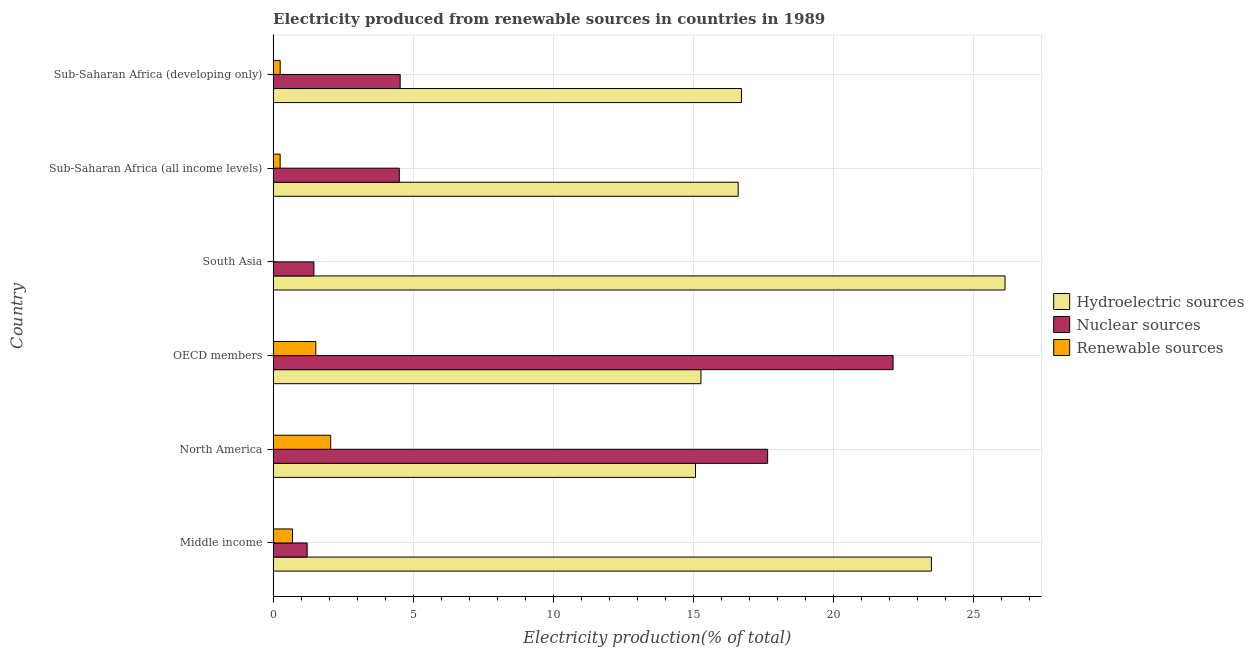How many different coloured bars are there?
Provide a short and direct response. 3. Are the number of bars per tick equal to the number of legend labels?
Give a very brief answer. Yes. How many bars are there on the 4th tick from the top?
Your response must be concise. 3. How many bars are there on the 3rd tick from the bottom?
Your answer should be compact. 3. What is the label of the 5th group of bars from the top?
Ensure brevity in your answer.  North America. What is the percentage of electricity produced by hydroelectric sources in Sub-Saharan Africa (all income levels)?
Your response must be concise. 16.61. Across all countries, what is the maximum percentage of electricity produced by hydroelectric sources?
Offer a terse response. 26.14. Across all countries, what is the minimum percentage of electricity produced by hydroelectric sources?
Your answer should be very brief. 15.09. In which country was the percentage of electricity produced by renewable sources minimum?
Your response must be concise. South Asia. What is the total percentage of electricity produced by renewable sources in the graph?
Provide a succinct answer. 4.78. What is the difference between the percentage of electricity produced by nuclear sources in North America and that in Sub-Saharan Africa (all income levels)?
Your answer should be compact. 13.16. What is the difference between the percentage of electricity produced by nuclear sources in South Asia and the percentage of electricity produced by renewable sources in Sub-Saharan Africa (developing only)?
Your response must be concise. 1.2. What is the average percentage of electricity produced by renewable sources per country?
Provide a succinct answer. 0.8. What is the difference between the percentage of electricity produced by renewable sources and percentage of electricity produced by hydroelectric sources in Middle income?
Give a very brief answer. -22.82. In how many countries, is the percentage of electricity produced by hydroelectric sources greater than 5 %?
Offer a very short reply. 6. What is the ratio of the percentage of electricity produced by nuclear sources in Middle income to that in North America?
Your response must be concise. 0.07. Is the percentage of electricity produced by nuclear sources in North America less than that in OECD members?
Keep it short and to the point. Yes. What is the difference between the highest and the second highest percentage of electricity produced by nuclear sources?
Ensure brevity in your answer.  4.48. What is the difference between the highest and the lowest percentage of electricity produced by renewable sources?
Provide a succinct answer. 2.05. In how many countries, is the percentage of electricity produced by renewable sources greater than the average percentage of electricity produced by renewable sources taken over all countries?
Your answer should be compact. 2. What does the 3rd bar from the top in Sub-Saharan Africa (all income levels) represents?
Offer a very short reply. Hydroelectric sources. What does the 3rd bar from the bottom in South Asia represents?
Provide a short and direct response. Renewable sources. Is it the case that in every country, the sum of the percentage of electricity produced by hydroelectric sources and percentage of electricity produced by nuclear sources is greater than the percentage of electricity produced by renewable sources?
Give a very brief answer. Yes. Are the values on the major ticks of X-axis written in scientific E-notation?
Your response must be concise. No. Does the graph contain any zero values?
Your response must be concise. No. What is the title of the graph?
Keep it short and to the point. Electricity produced from renewable sources in countries in 1989. Does "Other sectors" appear as one of the legend labels in the graph?
Your answer should be very brief. No. What is the label or title of the X-axis?
Provide a succinct answer. Electricity production(% of total). What is the Electricity production(% of total) of Hydroelectric sources in Middle income?
Your answer should be very brief. 23.51. What is the Electricity production(% of total) of Nuclear sources in Middle income?
Provide a short and direct response. 1.22. What is the Electricity production(% of total) of Renewable sources in Middle income?
Provide a short and direct response. 0.69. What is the Electricity production(% of total) of Hydroelectric sources in North America?
Your answer should be compact. 15.09. What is the Electricity production(% of total) of Nuclear sources in North America?
Offer a terse response. 17.66. What is the Electricity production(% of total) of Renewable sources in North America?
Make the answer very short. 2.06. What is the Electricity production(% of total) of Hydroelectric sources in OECD members?
Keep it short and to the point. 15.28. What is the Electricity production(% of total) in Nuclear sources in OECD members?
Make the answer very short. 22.15. What is the Electricity production(% of total) in Renewable sources in OECD members?
Give a very brief answer. 1.53. What is the Electricity production(% of total) in Hydroelectric sources in South Asia?
Make the answer very short. 26.14. What is the Electricity production(% of total) in Nuclear sources in South Asia?
Keep it short and to the point. 1.46. What is the Electricity production(% of total) of Renewable sources in South Asia?
Offer a very short reply. 0. What is the Electricity production(% of total) in Hydroelectric sources in Sub-Saharan Africa (all income levels)?
Offer a very short reply. 16.61. What is the Electricity production(% of total) in Nuclear sources in Sub-Saharan Africa (all income levels)?
Your answer should be very brief. 4.51. What is the Electricity production(% of total) in Renewable sources in Sub-Saharan Africa (all income levels)?
Offer a very short reply. 0.25. What is the Electricity production(% of total) in Hydroelectric sources in Sub-Saharan Africa (developing only)?
Your answer should be compact. 16.73. What is the Electricity production(% of total) of Nuclear sources in Sub-Saharan Africa (developing only)?
Give a very brief answer. 4.54. What is the Electricity production(% of total) of Renewable sources in Sub-Saharan Africa (developing only)?
Make the answer very short. 0.25. Across all countries, what is the maximum Electricity production(% of total) of Hydroelectric sources?
Offer a terse response. 26.14. Across all countries, what is the maximum Electricity production(% of total) of Nuclear sources?
Your answer should be compact. 22.15. Across all countries, what is the maximum Electricity production(% of total) in Renewable sources?
Offer a very short reply. 2.06. Across all countries, what is the minimum Electricity production(% of total) in Hydroelectric sources?
Your response must be concise. 15.09. Across all countries, what is the minimum Electricity production(% of total) in Nuclear sources?
Your answer should be compact. 1.22. Across all countries, what is the minimum Electricity production(% of total) in Renewable sources?
Provide a short and direct response. 0. What is the total Electricity production(% of total) of Hydroelectric sources in the graph?
Make the answer very short. 113.37. What is the total Electricity production(% of total) of Nuclear sources in the graph?
Keep it short and to the point. 51.53. What is the total Electricity production(% of total) in Renewable sources in the graph?
Your answer should be compact. 4.78. What is the difference between the Electricity production(% of total) in Hydroelectric sources in Middle income and that in North America?
Your response must be concise. 8.43. What is the difference between the Electricity production(% of total) of Nuclear sources in Middle income and that in North America?
Your response must be concise. -16.45. What is the difference between the Electricity production(% of total) in Renewable sources in Middle income and that in North America?
Your answer should be compact. -1.36. What is the difference between the Electricity production(% of total) of Hydroelectric sources in Middle income and that in OECD members?
Your response must be concise. 8.23. What is the difference between the Electricity production(% of total) in Nuclear sources in Middle income and that in OECD members?
Offer a very short reply. -20.93. What is the difference between the Electricity production(% of total) in Renewable sources in Middle income and that in OECD members?
Keep it short and to the point. -0.83. What is the difference between the Electricity production(% of total) of Hydroelectric sources in Middle income and that in South Asia?
Keep it short and to the point. -2.63. What is the difference between the Electricity production(% of total) in Nuclear sources in Middle income and that in South Asia?
Offer a very short reply. -0.24. What is the difference between the Electricity production(% of total) of Renewable sources in Middle income and that in South Asia?
Your response must be concise. 0.69. What is the difference between the Electricity production(% of total) in Hydroelectric sources in Middle income and that in Sub-Saharan Africa (all income levels)?
Your response must be concise. 6.9. What is the difference between the Electricity production(% of total) in Nuclear sources in Middle income and that in Sub-Saharan Africa (all income levels)?
Provide a short and direct response. -3.29. What is the difference between the Electricity production(% of total) in Renewable sources in Middle income and that in Sub-Saharan Africa (all income levels)?
Keep it short and to the point. 0.44. What is the difference between the Electricity production(% of total) in Hydroelectric sources in Middle income and that in Sub-Saharan Africa (developing only)?
Make the answer very short. 6.79. What is the difference between the Electricity production(% of total) in Nuclear sources in Middle income and that in Sub-Saharan Africa (developing only)?
Your answer should be very brief. -3.32. What is the difference between the Electricity production(% of total) of Renewable sources in Middle income and that in Sub-Saharan Africa (developing only)?
Your response must be concise. 0.44. What is the difference between the Electricity production(% of total) of Hydroelectric sources in North America and that in OECD members?
Your answer should be compact. -0.19. What is the difference between the Electricity production(% of total) in Nuclear sources in North America and that in OECD members?
Provide a succinct answer. -4.48. What is the difference between the Electricity production(% of total) of Renewable sources in North America and that in OECD members?
Your answer should be compact. 0.53. What is the difference between the Electricity production(% of total) of Hydroelectric sources in North America and that in South Asia?
Offer a terse response. -11.06. What is the difference between the Electricity production(% of total) of Nuclear sources in North America and that in South Asia?
Make the answer very short. 16.21. What is the difference between the Electricity production(% of total) in Renewable sources in North America and that in South Asia?
Provide a succinct answer. 2.05. What is the difference between the Electricity production(% of total) of Hydroelectric sources in North America and that in Sub-Saharan Africa (all income levels)?
Give a very brief answer. -1.52. What is the difference between the Electricity production(% of total) in Nuclear sources in North America and that in Sub-Saharan Africa (all income levels)?
Keep it short and to the point. 13.16. What is the difference between the Electricity production(% of total) in Renewable sources in North America and that in Sub-Saharan Africa (all income levels)?
Make the answer very short. 1.81. What is the difference between the Electricity production(% of total) of Hydroelectric sources in North America and that in Sub-Saharan Africa (developing only)?
Provide a short and direct response. -1.64. What is the difference between the Electricity production(% of total) of Nuclear sources in North America and that in Sub-Saharan Africa (developing only)?
Your response must be concise. 13.13. What is the difference between the Electricity production(% of total) of Renewable sources in North America and that in Sub-Saharan Africa (developing only)?
Offer a terse response. 1.8. What is the difference between the Electricity production(% of total) in Hydroelectric sources in OECD members and that in South Asia?
Make the answer very short. -10.86. What is the difference between the Electricity production(% of total) in Nuclear sources in OECD members and that in South Asia?
Provide a succinct answer. 20.69. What is the difference between the Electricity production(% of total) in Renewable sources in OECD members and that in South Asia?
Offer a very short reply. 1.52. What is the difference between the Electricity production(% of total) in Hydroelectric sources in OECD members and that in Sub-Saharan Africa (all income levels)?
Your response must be concise. -1.33. What is the difference between the Electricity production(% of total) of Nuclear sources in OECD members and that in Sub-Saharan Africa (all income levels)?
Your answer should be very brief. 17.64. What is the difference between the Electricity production(% of total) in Renewable sources in OECD members and that in Sub-Saharan Africa (all income levels)?
Keep it short and to the point. 1.28. What is the difference between the Electricity production(% of total) in Hydroelectric sources in OECD members and that in Sub-Saharan Africa (developing only)?
Provide a succinct answer. -1.45. What is the difference between the Electricity production(% of total) of Nuclear sources in OECD members and that in Sub-Saharan Africa (developing only)?
Your answer should be very brief. 17.61. What is the difference between the Electricity production(% of total) of Renewable sources in OECD members and that in Sub-Saharan Africa (developing only)?
Your answer should be very brief. 1.27. What is the difference between the Electricity production(% of total) in Hydroelectric sources in South Asia and that in Sub-Saharan Africa (all income levels)?
Your response must be concise. 9.53. What is the difference between the Electricity production(% of total) of Nuclear sources in South Asia and that in Sub-Saharan Africa (all income levels)?
Offer a very short reply. -3.05. What is the difference between the Electricity production(% of total) in Renewable sources in South Asia and that in Sub-Saharan Africa (all income levels)?
Ensure brevity in your answer.  -0.25. What is the difference between the Electricity production(% of total) in Hydroelectric sources in South Asia and that in Sub-Saharan Africa (developing only)?
Provide a succinct answer. 9.42. What is the difference between the Electricity production(% of total) of Nuclear sources in South Asia and that in Sub-Saharan Africa (developing only)?
Provide a succinct answer. -3.08. What is the difference between the Electricity production(% of total) in Renewable sources in South Asia and that in Sub-Saharan Africa (developing only)?
Your answer should be very brief. -0.25. What is the difference between the Electricity production(% of total) in Hydroelectric sources in Sub-Saharan Africa (all income levels) and that in Sub-Saharan Africa (developing only)?
Make the answer very short. -0.12. What is the difference between the Electricity production(% of total) in Nuclear sources in Sub-Saharan Africa (all income levels) and that in Sub-Saharan Africa (developing only)?
Provide a short and direct response. -0.03. What is the difference between the Electricity production(% of total) of Renewable sources in Sub-Saharan Africa (all income levels) and that in Sub-Saharan Africa (developing only)?
Offer a very short reply. -0. What is the difference between the Electricity production(% of total) of Hydroelectric sources in Middle income and the Electricity production(% of total) of Nuclear sources in North America?
Give a very brief answer. 5.85. What is the difference between the Electricity production(% of total) of Hydroelectric sources in Middle income and the Electricity production(% of total) of Renewable sources in North America?
Make the answer very short. 21.46. What is the difference between the Electricity production(% of total) in Nuclear sources in Middle income and the Electricity production(% of total) in Renewable sources in North America?
Your answer should be compact. -0.84. What is the difference between the Electricity production(% of total) of Hydroelectric sources in Middle income and the Electricity production(% of total) of Nuclear sources in OECD members?
Your response must be concise. 1.37. What is the difference between the Electricity production(% of total) of Hydroelectric sources in Middle income and the Electricity production(% of total) of Renewable sources in OECD members?
Make the answer very short. 21.99. What is the difference between the Electricity production(% of total) in Nuclear sources in Middle income and the Electricity production(% of total) in Renewable sources in OECD members?
Offer a very short reply. -0.31. What is the difference between the Electricity production(% of total) in Hydroelectric sources in Middle income and the Electricity production(% of total) in Nuclear sources in South Asia?
Your answer should be very brief. 22.06. What is the difference between the Electricity production(% of total) of Hydroelectric sources in Middle income and the Electricity production(% of total) of Renewable sources in South Asia?
Provide a succinct answer. 23.51. What is the difference between the Electricity production(% of total) in Nuclear sources in Middle income and the Electricity production(% of total) in Renewable sources in South Asia?
Provide a succinct answer. 1.21. What is the difference between the Electricity production(% of total) of Hydroelectric sources in Middle income and the Electricity production(% of total) of Nuclear sources in Sub-Saharan Africa (all income levels)?
Your answer should be very brief. 19.01. What is the difference between the Electricity production(% of total) of Hydroelectric sources in Middle income and the Electricity production(% of total) of Renewable sources in Sub-Saharan Africa (all income levels)?
Your answer should be very brief. 23.26. What is the difference between the Electricity production(% of total) of Nuclear sources in Middle income and the Electricity production(% of total) of Renewable sources in Sub-Saharan Africa (all income levels)?
Keep it short and to the point. 0.97. What is the difference between the Electricity production(% of total) of Hydroelectric sources in Middle income and the Electricity production(% of total) of Nuclear sources in Sub-Saharan Africa (developing only)?
Provide a succinct answer. 18.98. What is the difference between the Electricity production(% of total) of Hydroelectric sources in Middle income and the Electricity production(% of total) of Renewable sources in Sub-Saharan Africa (developing only)?
Ensure brevity in your answer.  23.26. What is the difference between the Electricity production(% of total) in Nuclear sources in Middle income and the Electricity production(% of total) in Renewable sources in Sub-Saharan Africa (developing only)?
Offer a very short reply. 0.96. What is the difference between the Electricity production(% of total) in Hydroelectric sources in North America and the Electricity production(% of total) in Nuclear sources in OECD members?
Provide a succinct answer. -7.06. What is the difference between the Electricity production(% of total) of Hydroelectric sources in North America and the Electricity production(% of total) of Renewable sources in OECD members?
Provide a short and direct response. 13.56. What is the difference between the Electricity production(% of total) of Nuclear sources in North America and the Electricity production(% of total) of Renewable sources in OECD members?
Give a very brief answer. 16.14. What is the difference between the Electricity production(% of total) of Hydroelectric sources in North America and the Electricity production(% of total) of Nuclear sources in South Asia?
Your answer should be very brief. 13.63. What is the difference between the Electricity production(% of total) of Hydroelectric sources in North America and the Electricity production(% of total) of Renewable sources in South Asia?
Make the answer very short. 15.09. What is the difference between the Electricity production(% of total) of Nuclear sources in North America and the Electricity production(% of total) of Renewable sources in South Asia?
Keep it short and to the point. 17.66. What is the difference between the Electricity production(% of total) of Hydroelectric sources in North America and the Electricity production(% of total) of Nuclear sources in Sub-Saharan Africa (all income levels)?
Offer a terse response. 10.58. What is the difference between the Electricity production(% of total) in Hydroelectric sources in North America and the Electricity production(% of total) in Renewable sources in Sub-Saharan Africa (all income levels)?
Keep it short and to the point. 14.84. What is the difference between the Electricity production(% of total) in Nuclear sources in North America and the Electricity production(% of total) in Renewable sources in Sub-Saharan Africa (all income levels)?
Make the answer very short. 17.41. What is the difference between the Electricity production(% of total) of Hydroelectric sources in North America and the Electricity production(% of total) of Nuclear sources in Sub-Saharan Africa (developing only)?
Give a very brief answer. 10.55. What is the difference between the Electricity production(% of total) in Hydroelectric sources in North America and the Electricity production(% of total) in Renewable sources in Sub-Saharan Africa (developing only)?
Provide a short and direct response. 14.84. What is the difference between the Electricity production(% of total) in Nuclear sources in North America and the Electricity production(% of total) in Renewable sources in Sub-Saharan Africa (developing only)?
Provide a short and direct response. 17.41. What is the difference between the Electricity production(% of total) of Hydroelectric sources in OECD members and the Electricity production(% of total) of Nuclear sources in South Asia?
Offer a terse response. 13.83. What is the difference between the Electricity production(% of total) of Hydroelectric sources in OECD members and the Electricity production(% of total) of Renewable sources in South Asia?
Keep it short and to the point. 15.28. What is the difference between the Electricity production(% of total) in Nuclear sources in OECD members and the Electricity production(% of total) in Renewable sources in South Asia?
Offer a very short reply. 22.14. What is the difference between the Electricity production(% of total) of Hydroelectric sources in OECD members and the Electricity production(% of total) of Nuclear sources in Sub-Saharan Africa (all income levels)?
Your answer should be compact. 10.78. What is the difference between the Electricity production(% of total) of Hydroelectric sources in OECD members and the Electricity production(% of total) of Renewable sources in Sub-Saharan Africa (all income levels)?
Keep it short and to the point. 15.03. What is the difference between the Electricity production(% of total) in Nuclear sources in OECD members and the Electricity production(% of total) in Renewable sources in Sub-Saharan Africa (all income levels)?
Keep it short and to the point. 21.89. What is the difference between the Electricity production(% of total) of Hydroelectric sources in OECD members and the Electricity production(% of total) of Nuclear sources in Sub-Saharan Africa (developing only)?
Make the answer very short. 10.74. What is the difference between the Electricity production(% of total) of Hydroelectric sources in OECD members and the Electricity production(% of total) of Renewable sources in Sub-Saharan Africa (developing only)?
Provide a succinct answer. 15.03. What is the difference between the Electricity production(% of total) of Nuclear sources in OECD members and the Electricity production(% of total) of Renewable sources in Sub-Saharan Africa (developing only)?
Ensure brevity in your answer.  21.89. What is the difference between the Electricity production(% of total) of Hydroelectric sources in South Asia and the Electricity production(% of total) of Nuclear sources in Sub-Saharan Africa (all income levels)?
Keep it short and to the point. 21.64. What is the difference between the Electricity production(% of total) in Hydroelectric sources in South Asia and the Electricity production(% of total) in Renewable sources in Sub-Saharan Africa (all income levels)?
Ensure brevity in your answer.  25.89. What is the difference between the Electricity production(% of total) in Nuclear sources in South Asia and the Electricity production(% of total) in Renewable sources in Sub-Saharan Africa (all income levels)?
Offer a very short reply. 1.21. What is the difference between the Electricity production(% of total) in Hydroelectric sources in South Asia and the Electricity production(% of total) in Nuclear sources in Sub-Saharan Africa (developing only)?
Provide a short and direct response. 21.61. What is the difference between the Electricity production(% of total) in Hydroelectric sources in South Asia and the Electricity production(% of total) in Renewable sources in Sub-Saharan Africa (developing only)?
Your answer should be very brief. 25.89. What is the difference between the Electricity production(% of total) in Nuclear sources in South Asia and the Electricity production(% of total) in Renewable sources in Sub-Saharan Africa (developing only)?
Give a very brief answer. 1.2. What is the difference between the Electricity production(% of total) in Hydroelectric sources in Sub-Saharan Africa (all income levels) and the Electricity production(% of total) in Nuclear sources in Sub-Saharan Africa (developing only)?
Keep it short and to the point. 12.07. What is the difference between the Electricity production(% of total) in Hydroelectric sources in Sub-Saharan Africa (all income levels) and the Electricity production(% of total) in Renewable sources in Sub-Saharan Africa (developing only)?
Your answer should be compact. 16.36. What is the difference between the Electricity production(% of total) of Nuclear sources in Sub-Saharan Africa (all income levels) and the Electricity production(% of total) of Renewable sources in Sub-Saharan Africa (developing only)?
Provide a short and direct response. 4.25. What is the average Electricity production(% of total) of Hydroelectric sources per country?
Your answer should be compact. 18.89. What is the average Electricity production(% of total) of Nuclear sources per country?
Keep it short and to the point. 8.59. What is the average Electricity production(% of total) in Renewable sources per country?
Offer a terse response. 0.8. What is the difference between the Electricity production(% of total) of Hydroelectric sources and Electricity production(% of total) of Nuclear sources in Middle income?
Your answer should be very brief. 22.3. What is the difference between the Electricity production(% of total) of Hydroelectric sources and Electricity production(% of total) of Renewable sources in Middle income?
Offer a terse response. 22.82. What is the difference between the Electricity production(% of total) of Nuclear sources and Electricity production(% of total) of Renewable sources in Middle income?
Your answer should be compact. 0.52. What is the difference between the Electricity production(% of total) in Hydroelectric sources and Electricity production(% of total) in Nuclear sources in North America?
Offer a terse response. -2.58. What is the difference between the Electricity production(% of total) of Hydroelectric sources and Electricity production(% of total) of Renewable sources in North America?
Provide a succinct answer. 13.03. What is the difference between the Electricity production(% of total) in Nuclear sources and Electricity production(% of total) in Renewable sources in North America?
Make the answer very short. 15.61. What is the difference between the Electricity production(% of total) in Hydroelectric sources and Electricity production(% of total) in Nuclear sources in OECD members?
Make the answer very short. -6.86. What is the difference between the Electricity production(% of total) of Hydroelectric sources and Electricity production(% of total) of Renewable sources in OECD members?
Make the answer very short. 13.76. What is the difference between the Electricity production(% of total) of Nuclear sources and Electricity production(% of total) of Renewable sources in OECD members?
Your answer should be very brief. 20.62. What is the difference between the Electricity production(% of total) in Hydroelectric sources and Electricity production(% of total) in Nuclear sources in South Asia?
Your answer should be very brief. 24.69. What is the difference between the Electricity production(% of total) in Hydroelectric sources and Electricity production(% of total) in Renewable sources in South Asia?
Offer a very short reply. 26.14. What is the difference between the Electricity production(% of total) of Nuclear sources and Electricity production(% of total) of Renewable sources in South Asia?
Offer a terse response. 1.46. What is the difference between the Electricity production(% of total) in Hydroelectric sources and Electricity production(% of total) in Nuclear sources in Sub-Saharan Africa (all income levels)?
Provide a succinct answer. 12.11. What is the difference between the Electricity production(% of total) in Hydroelectric sources and Electricity production(% of total) in Renewable sources in Sub-Saharan Africa (all income levels)?
Provide a succinct answer. 16.36. What is the difference between the Electricity production(% of total) of Nuclear sources and Electricity production(% of total) of Renewable sources in Sub-Saharan Africa (all income levels)?
Provide a short and direct response. 4.26. What is the difference between the Electricity production(% of total) in Hydroelectric sources and Electricity production(% of total) in Nuclear sources in Sub-Saharan Africa (developing only)?
Offer a very short reply. 12.19. What is the difference between the Electricity production(% of total) in Hydroelectric sources and Electricity production(% of total) in Renewable sources in Sub-Saharan Africa (developing only)?
Keep it short and to the point. 16.48. What is the difference between the Electricity production(% of total) of Nuclear sources and Electricity production(% of total) of Renewable sources in Sub-Saharan Africa (developing only)?
Provide a short and direct response. 4.29. What is the ratio of the Electricity production(% of total) in Hydroelectric sources in Middle income to that in North America?
Ensure brevity in your answer.  1.56. What is the ratio of the Electricity production(% of total) of Nuclear sources in Middle income to that in North America?
Provide a succinct answer. 0.07. What is the ratio of the Electricity production(% of total) of Renewable sources in Middle income to that in North America?
Make the answer very short. 0.34. What is the ratio of the Electricity production(% of total) in Hydroelectric sources in Middle income to that in OECD members?
Your response must be concise. 1.54. What is the ratio of the Electricity production(% of total) in Nuclear sources in Middle income to that in OECD members?
Provide a short and direct response. 0.05. What is the ratio of the Electricity production(% of total) in Renewable sources in Middle income to that in OECD members?
Offer a very short reply. 0.45. What is the ratio of the Electricity production(% of total) of Hydroelectric sources in Middle income to that in South Asia?
Your response must be concise. 0.9. What is the ratio of the Electricity production(% of total) of Nuclear sources in Middle income to that in South Asia?
Give a very brief answer. 0.83. What is the ratio of the Electricity production(% of total) in Renewable sources in Middle income to that in South Asia?
Your answer should be very brief. 369.14. What is the ratio of the Electricity production(% of total) in Hydroelectric sources in Middle income to that in Sub-Saharan Africa (all income levels)?
Provide a succinct answer. 1.42. What is the ratio of the Electricity production(% of total) of Nuclear sources in Middle income to that in Sub-Saharan Africa (all income levels)?
Provide a short and direct response. 0.27. What is the ratio of the Electricity production(% of total) of Renewable sources in Middle income to that in Sub-Saharan Africa (all income levels)?
Offer a terse response. 2.77. What is the ratio of the Electricity production(% of total) in Hydroelectric sources in Middle income to that in Sub-Saharan Africa (developing only)?
Your response must be concise. 1.41. What is the ratio of the Electricity production(% of total) in Nuclear sources in Middle income to that in Sub-Saharan Africa (developing only)?
Ensure brevity in your answer.  0.27. What is the ratio of the Electricity production(% of total) in Renewable sources in Middle income to that in Sub-Saharan Africa (developing only)?
Provide a short and direct response. 2.75. What is the ratio of the Electricity production(% of total) in Hydroelectric sources in North America to that in OECD members?
Give a very brief answer. 0.99. What is the ratio of the Electricity production(% of total) in Nuclear sources in North America to that in OECD members?
Offer a very short reply. 0.8. What is the ratio of the Electricity production(% of total) in Renewable sources in North America to that in OECD members?
Your answer should be very brief. 1.35. What is the ratio of the Electricity production(% of total) in Hydroelectric sources in North America to that in South Asia?
Offer a terse response. 0.58. What is the ratio of the Electricity production(% of total) in Nuclear sources in North America to that in South Asia?
Provide a short and direct response. 12.13. What is the ratio of the Electricity production(% of total) in Renewable sources in North America to that in South Asia?
Provide a short and direct response. 1095.07. What is the ratio of the Electricity production(% of total) in Hydroelectric sources in North America to that in Sub-Saharan Africa (all income levels)?
Your response must be concise. 0.91. What is the ratio of the Electricity production(% of total) in Nuclear sources in North America to that in Sub-Saharan Africa (all income levels)?
Give a very brief answer. 3.92. What is the ratio of the Electricity production(% of total) of Renewable sources in North America to that in Sub-Saharan Africa (all income levels)?
Give a very brief answer. 8.21. What is the ratio of the Electricity production(% of total) in Hydroelectric sources in North America to that in Sub-Saharan Africa (developing only)?
Offer a terse response. 0.9. What is the ratio of the Electricity production(% of total) in Nuclear sources in North America to that in Sub-Saharan Africa (developing only)?
Provide a short and direct response. 3.89. What is the ratio of the Electricity production(% of total) of Renewable sources in North America to that in Sub-Saharan Africa (developing only)?
Keep it short and to the point. 8.15. What is the ratio of the Electricity production(% of total) of Hydroelectric sources in OECD members to that in South Asia?
Make the answer very short. 0.58. What is the ratio of the Electricity production(% of total) of Nuclear sources in OECD members to that in South Asia?
Your answer should be very brief. 15.2. What is the ratio of the Electricity production(% of total) of Renewable sources in OECD members to that in South Asia?
Ensure brevity in your answer.  812.46. What is the ratio of the Electricity production(% of total) of Hydroelectric sources in OECD members to that in Sub-Saharan Africa (all income levels)?
Offer a terse response. 0.92. What is the ratio of the Electricity production(% of total) of Nuclear sources in OECD members to that in Sub-Saharan Africa (all income levels)?
Make the answer very short. 4.91. What is the ratio of the Electricity production(% of total) of Renewable sources in OECD members to that in Sub-Saharan Africa (all income levels)?
Your answer should be compact. 6.09. What is the ratio of the Electricity production(% of total) of Hydroelectric sources in OECD members to that in Sub-Saharan Africa (developing only)?
Your answer should be compact. 0.91. What is the ratio of the Electricity production(% of total) in Nuclear sources in OECD members to that in Sub-Saharan Africa (developing only)?
Your answer should be very brief. 4.88. What is the ratio of the Electricity production(% of total) in Renewable sources in OECD members to that in Sub-Saharan Africa (developing only)?
Your response must be concise. 6.05. What is the ratio of the Electricity production(% of total) in Hydroelectric sources in South Asia to that in Sub-Saharan Africa (all income levels)?
Give a very brief answer. 1.57. What is the ratio of the Electricity production(% of total) of Nuclear sources in South Asia to that in Sub-Saharan Africa (all income levels)?
Your response must be concise. 0.32. What is the ratio of the Electricity production(% of total) in Renewable sources in South Asia to that in Sub-Saharan Africa (all income levels)?
Ensure brevity in your answer.  0.01. What is the ratio of the Electricity production(% of total) of Hydroelectric sources in South Asia to that in Sub-Saharan Africa (developing only)?
Your response must be concise. 1.56. What is the ratio of the Electricity production(% of total) in Nuclear sources in South Asia to that in Sub-Saharan Africa (developing only)?
Offer a very short reply. 0.32. What is the ratio of the Electricity production(% of total) in Renewable sources in South Asia to that in Sub-Saharan Africa (developing only)?
Offer a very short reply. 0.01. What is the ratio of the Electricity production(% of total) of Hydroelectric sources in Sub-Saharan Africa (all income levels) to that in Sub-Saharan Africa (developing only)?
Your answer should be very brief. 0.99. What is the difference between the highest and the second highest Electricity production(% of total) in Hydroelectric sources?
Offer a very short reply. 2.63. What is the difference between the highest and the second highest Electricity production(% of total) of Nuclear sources?
Offer a terse response. 4.48. What is the difference between the highest and the second highest Electricity production(% of total) in Renewable sources?
Your response must be concise. 0.53. What is the difference between the highest and the lowest Electricity production(% of total) in Hydroelectric sources?
Your answer should be very brief. 11.06. What is the difference between the highest and the lowest Electricity production(% of total) in Nuclear sources?
Ensure brevity in your answer.  20.93. What is the difference between the highest and the lowest Electricity production(% of total) in Renewable sources?
Provide a short and direct response. 2.05. 